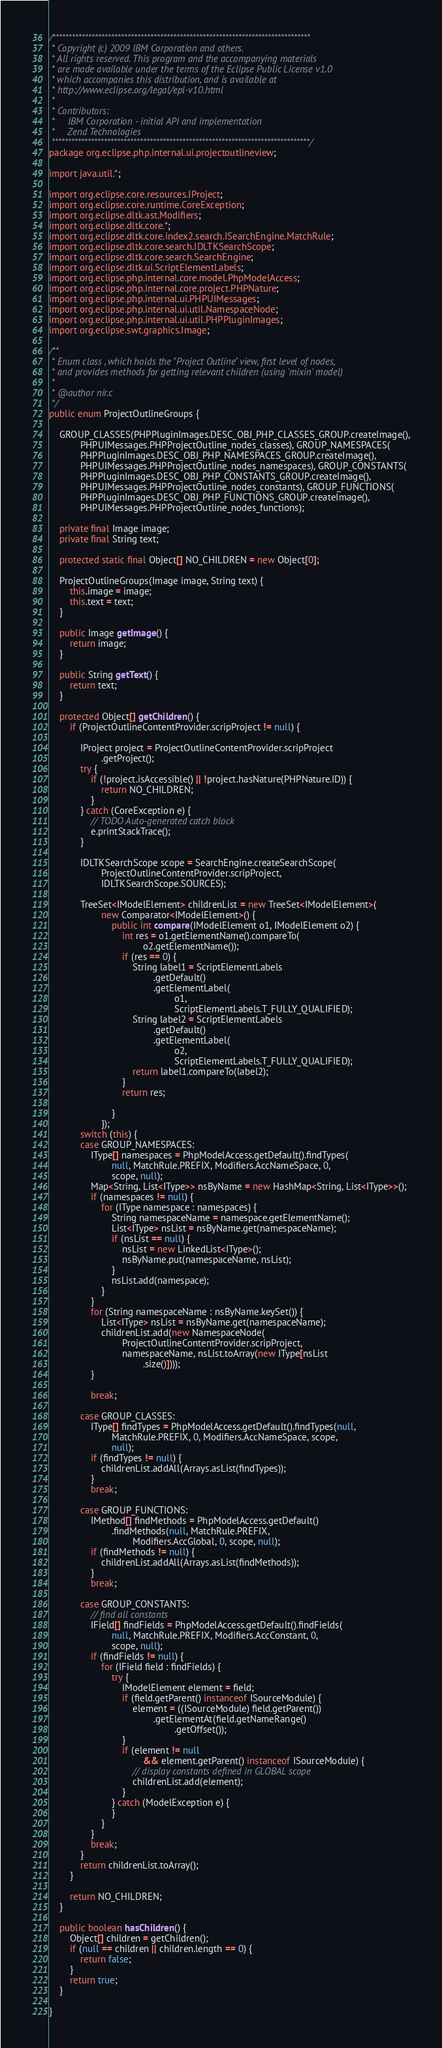Convert code to text. <code><loc_0><loc_0><loc_500><loc_500><_Java_>/*******************************************************************************
 * Copyright (c) 2009 IBM Corporation and others.
 * All rights reserved. This program and the accompanying materials
 * are made available under the terms of the Eclipse Public License v1.0
 * which accompanies this distribution, and is available at
 * http://www.eclipse.org/legal/epl-v10.html
 * 
 * Contributors:
 *     IBM Corporation - initial API and implementation
 *     Zend Technologies
 *******************************************************************************/
package org.eclipse.php.internal.ui.projectoutlineview;

import java.util.*;

import org.eclipse.core.resources.IProject;
import org.eclipse.core.runtime.CoreException;
import org.eclipse.dltk.ast.Modifiers;
import org.eclipse.dltk.core.*;
import org.eclipse.dltk.core.index2.search.ISearchEngine.MatchRule;
import org.eclipse.dltk.core.search.IDLTKSearchScope;
import org.eclipse.dltk.core.search.SearchEngine;
import org.eclipse.dltk.ui.ScriptElementLabels;
import org.eclipse.php.internal.core.model.PhpModelAccess;
import org.eclipse.php.internal.core.project.PHPNature;
import org.eclipse.php.internal.ui.PHPUIMessages;
import org.eclipse.php.internal.ui.util.NamespaceNode;
import org.eclipse.php.internal.ui.util.PHPPluginImages;
import org.eclipse.swt.graphics.Image;

/**
 * Enum class , which holds the "Project Outline" view, first level of nodes,
 * and provides methods for getting relevant children (using 'mixin' model)
 * 
 * @author nir.c
 */
public enum ProjectOutlineGroups {

	GROUP_CLASSES(PHPPluginImages.DESC_OBJ_PHP_CLASSES_GROUP.createImage(),
			PHPUIMessages.PHPProjectOutline_nodes_classes), GROUP_NAMESPACES(
			PHPPluginImages.DESC_OBJ_PHP_NAMESPACES_GROUP.createImage(),
			PHPUIMessages.PHPProjectOutline_nodes_namespaces), GROUP_CONSTANTS(
			PHPPluginImages.DESC_OBJ_PHP_CONSTANTS_GROUP.createImage(),
			PHPUIMessages.PHPProjectOutline_nodes_constants), GROUP_FUNCTIONS(
			PHPPluginImages.DESC_OBJ_PHP_FUNCTIONS_GROUP.createImage(),
			PHPUIMessages.PHPProjectOutline_nodes_functions);

	private final Image image;
	private final String text;

	protected static final Object[] NO_CHILDREN = new Object[0];

	ProjectOutlineGroups(Image image, String text) {
		this.image = image;
		this.text = text;
	}

	public Image getImage() {
		return image;
	}

	public String getText() {
		return text;
	}

	protected Object[] getChildren() {
		if (ProjectOutlineContentProvider.scripProject != null) {

			IProject project = ProjectOutlineContentProvider.scripProject
					.getProject();
			try {
				if (!project.isAccessible() || !project.hasNature(PHPNature.ID)) {
					return NO_CHILDREN;
				}
			} catch (CoreException e) {
				// TODO Auto-generated catch block
				e.printStackTrace();
			}

			IDLTKSearchScope scope = SearchEngine.createSearchScope(
					ProjectOutlineContentProvider.scripProject,
					IDLTKSearchScope.SOURCES);

			TreeSet<IModelElement> childrenList = new TreeSet<IModelElement>(
					new Comparator<IModelElement>() {
						public int compare(IModelElement o1, IModelElement o2) {
							int res = o1.getElementName().compareTo(
									o2.getElementName());
							if (res == 0) {
								String label1 = ScriptElementLabels
										.getDefault()
										.getElementLabel(
												o1,
												ScriptElementLabels.T_FULLY_QUALIFIED);
								String label2 = ScriptElementLabels
										.getDefault()
										.getElementLabel(
												o2,
												ScriptElementLabels.T_FULLY_QUALIFIED);
								return label1.compareTo(label2);
							}
							return res;

						}
					});
			switch (this) {
			case GROUP_NAMESPACES:
				IType[] namespaces = PhpModelAccess.getDefault().findTypes(
						null, MatchRule.PREFIX, Modifiers.AccNameSpace, 0,
						scope, null);
				Map<String, List<IType>> nsByName = new HashMap<String, List<IType>>();
				if (namespaces != null) {
					for (IType namespace : namespaces) {
						String namespaceName = namespace.getElementName();
						List<IType> nsList = nsByName.get(namespaceName);
						if (nsList == null) {
							nsList = new LinkedList<IType>();
							nsByName.put(namespaceName, nsList);
						}
						nsList.add(namespace);
					}
				}
				for (String namespaceName : nsByName.keySet()) {
					List<IType> nsList = nsByName.get(namespaceName);
					childrenList.add(new NamespaceNode(
							ProjectOutlineContentProvider.scripProject,
							namespaceName, nsList.toArray(new IType[nsList
									.size()])));
				}

				break;

			case GROUP_CLASSES:
				IType[] findTypes = PhpModelAccess.getDefault().findTypes(null,
						MatchRule.PREFIX, 0, Modifiers.AccNameSpace, scope,
						null);
				if (findTypes != null) {
					childrenList.addAll(Arrays.asList(findTypes));
				}
				break;

			case GROUP_FUNCTIONS:
				IMethod[] findMethods = PhpModelAccess.getDefault()
						.findMethods(null, MatchRule.PREFIX,
								Modifiers.AccGlobal, 0, scope, null);
				if (findMethods != null) {
					childrenList.addAll(Arrays.asList(findMethods));
				}
				break;

			case GROUP_CONSTANTS:
				// find all constants
				IField[] findFields = PhpModelAccess.getDefault().findFields(
						null, MatchRule.PREFIX, Modifiers.AccConstant, 0,
						scope, null);
				if (findFields != null) {
					for (IField field : findFields) {
						try {
							IModelElement element = field;
							if (field.getParent() instanceof ISourceModule) {
								element = ((ISourceModule) field.getParent())
										.getElementAt(field.getNameRange()
												.getOffset());
							}
							if (element != null
									&& element.getParent() instanceof ISourceModule) {
								// display constants defined in GLOBAL scope
								childrenList.add(element);
							}
						} catch (ModelException e) {
						}
					}
				}
				break;
			}
			return childrenList.toArray();
		}

		return NO_CHILDREN;
	}

	public boolean hasChildren() {
		Object[] children = getChildren();
		if (null == children || children.length == 0) {
			return false;
		}
		return true;
	}

}</code> 